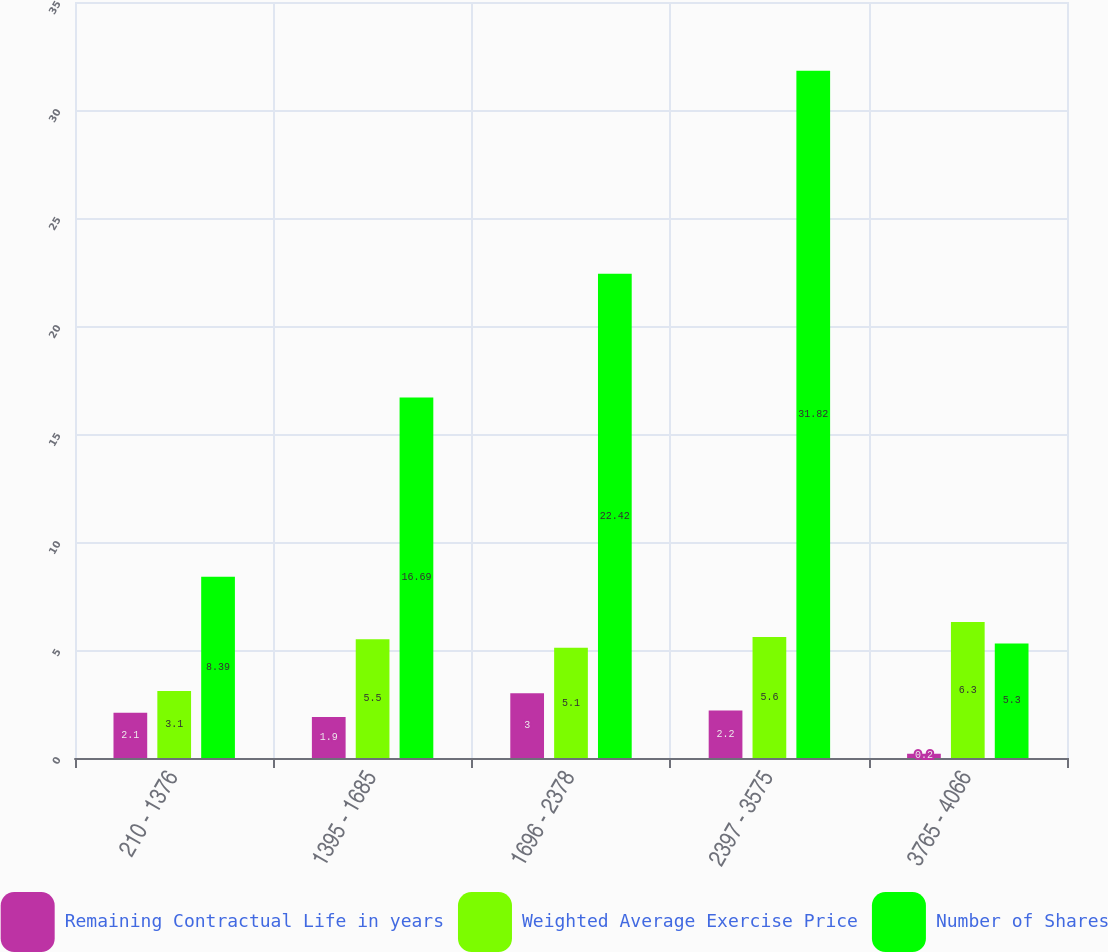Convert chart to OTSL. <chart><loc_0><loc_0><loc_500><loc_500><stacked_bar_chart><ecel><fcel>210 - 1376<fcel>1395 - 1685<fcel>1696 - 2378<fcel>2397 - 3575<fcel>3765 - 4066<nl><fcel>Remaining Contractual Life in years<fcel>2.1<fcel>1.9<fcel>3<fcel>2.2<fcel>0.2<nl><fcel>Weighted Average Exercise Price<fcel>3.1<fcel>5.5<fcel>5.1<fcel>5.6<fcel>6.3<nl><fcel>Number of Shares<fcel>8.39<fcel>16.69<fcel>22.42<fcel>31.82<fcel>5.3<nl></chart> 